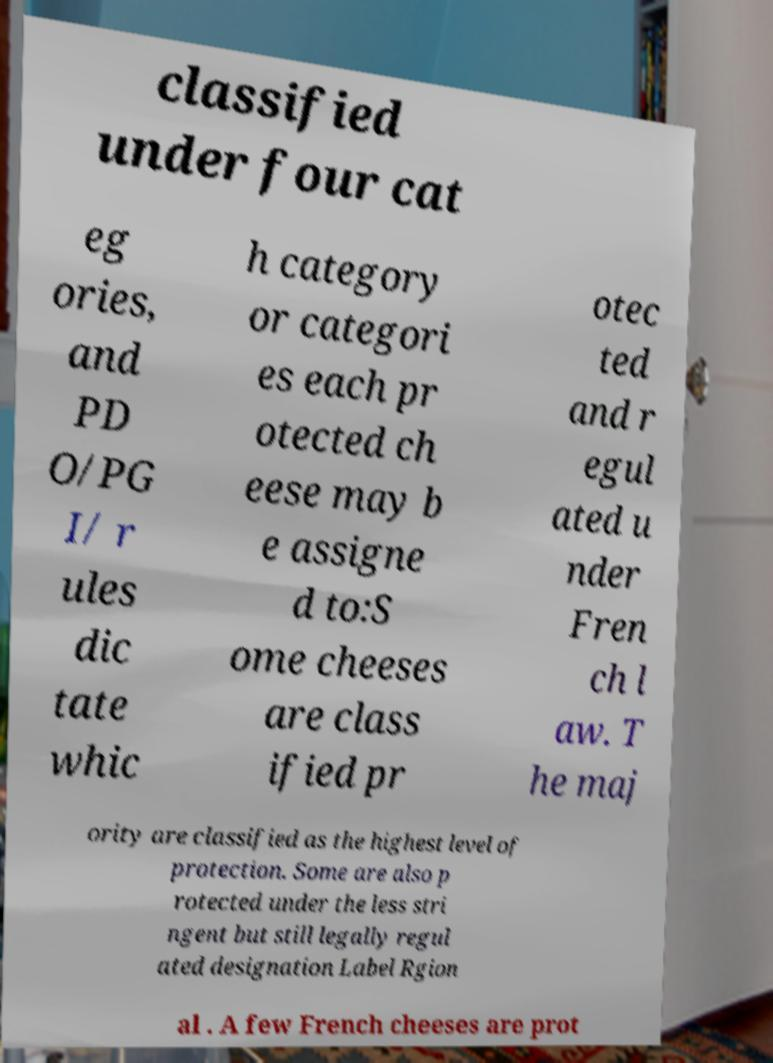There's text embedded in this image that I need extracted. Can you transcribe it verbatim? classified under four cat eg ories, and PD O/PG I/ r ules dic tate whic h category or categori es each pr otected ch eese may b e assigne d to:S ome cheeses are class ified pr otec ted and r egul ated u nder Fren ch l aw. T he maj ority are classified as the highest level of protection. Some are also p rotected under the less stri ngent but still legally regul ated designation Label Rgion al . A few French cheeses are prot 